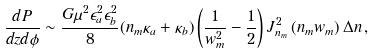<formula> <loc_0><loc_0><loc_500><loc_500>\frac { d P } { d z d \phi } \sim \frac { G \mu ^ { 2 } \epsilon ^ { 2 } _ { a } \epsilon _ { b } ^ { 2 } } { 8 } ( n _ { m } \kappa _ { a } + \kappa _ { b } ) \left ( \frac { 1 } { w _ { m } ^ { 2 } } - \frac { 1 } { 2 } \right ) J ^ { 2 } _ { n _ { m } } \left ( n _ { m } w _ { m } \right ) \Delta n \, ,</formula> 